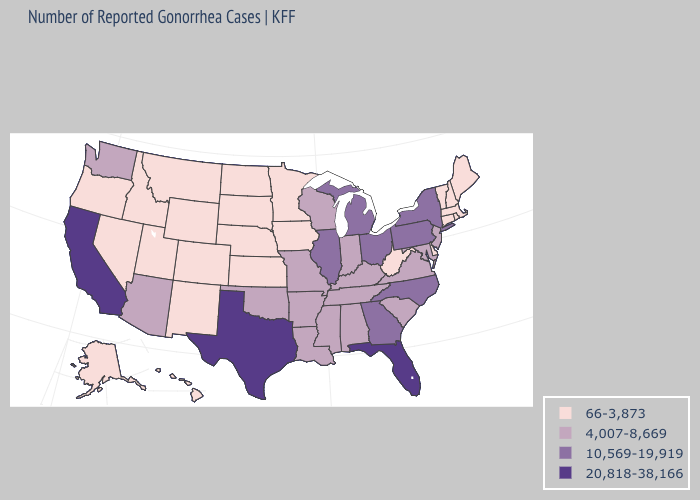Which states have the lowest value in the USA?
Concise answer only. Alaska, Colorado, Connecticut, Delaware, Hawaii, Idaho, Iowa, Kansas, Maine, Massachusetts, Minnesota, Montana, Nebraska, Nevada, New Hampshire, New Mexico, North Dakota, Oregon, Rhode Island, South Dakota, Utah, Vermont, West Virginia, Wyoming. Among the states that border Missouri , which have the lowest value?
Short answer required. Iowa, Kansas, Nebraska. Among the states that border Ohio , which have the highest value?
Answer briefly. Michigan, Pennsylvania. Does the map have missing data?
Give a very brief answer. No. Which states have the lowest value in the USA?
Be succinct. Alaska, Colorado, Connecticut, Delaware, Hawaii, Idaho, Iowa, Kansas, Maine, Massachusetts, Minnesota, Montana, Nebraska, Nevada, New Hampshire, New Mexico, North Dakota, Oregon, Rhode Island, South Dakota, Utah, Vermont, West Virginia, Wyoming. Is the legend a continuous bar?
Keep it brief. No. What is the value of Maryland?
Be succinct. 4,007-8,669. What is the value of New Jersey?
Quick response, please. 4,007-8,669. Name the states that have a value in the range 4,007-8,669?
Concise answer only. Alabama, Arizona, Arkansas, Indiana, Kentucky, Louisiana, Maryland, Mississippi, Missouri, New Jersey, Oklahoma, South Carolina, Tennessee, Virginia, Washington, Wisconsin. Is the legend a continuous bar?
Short answer required. No. Name the states that have a value in the range 20,818-38,166?
Keep it brief. California, Florida, Texas. What is the highest value in the USA?
Concise answer only. 20,818-38,166. What is the value of Massachusetts?
Answer briefly. 66-3,873. 